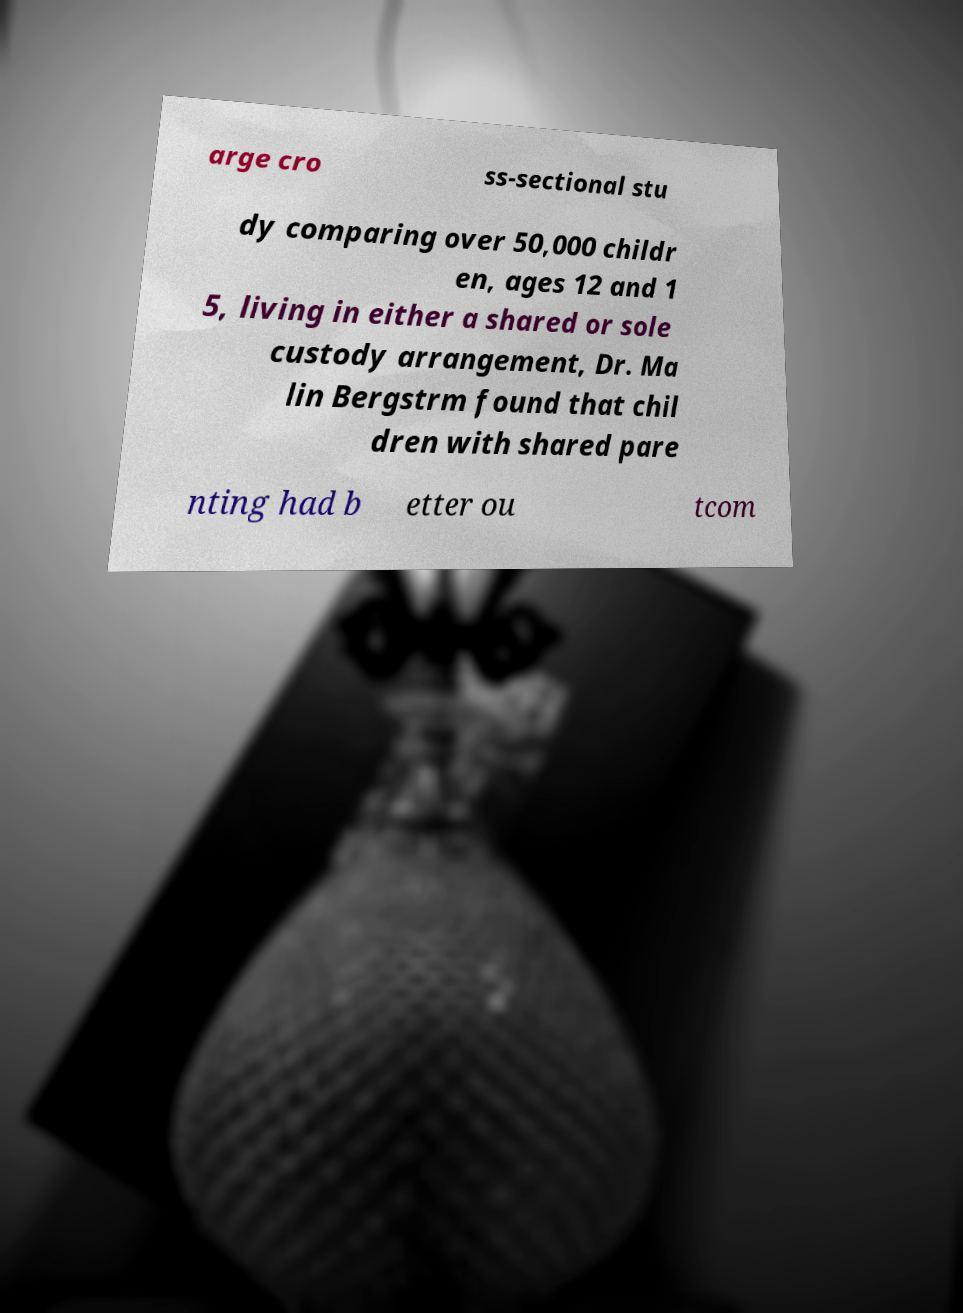Could you extract and type out the text from this image? arge cro ss-sectional stu dy comparing over 50,000 childr en, ages 12 and 1 5, living in either a shared or sole custody arrangement, Dr. Ma lin Bergstrm found that chil dren with shared pare nting had b etter ou tcom 